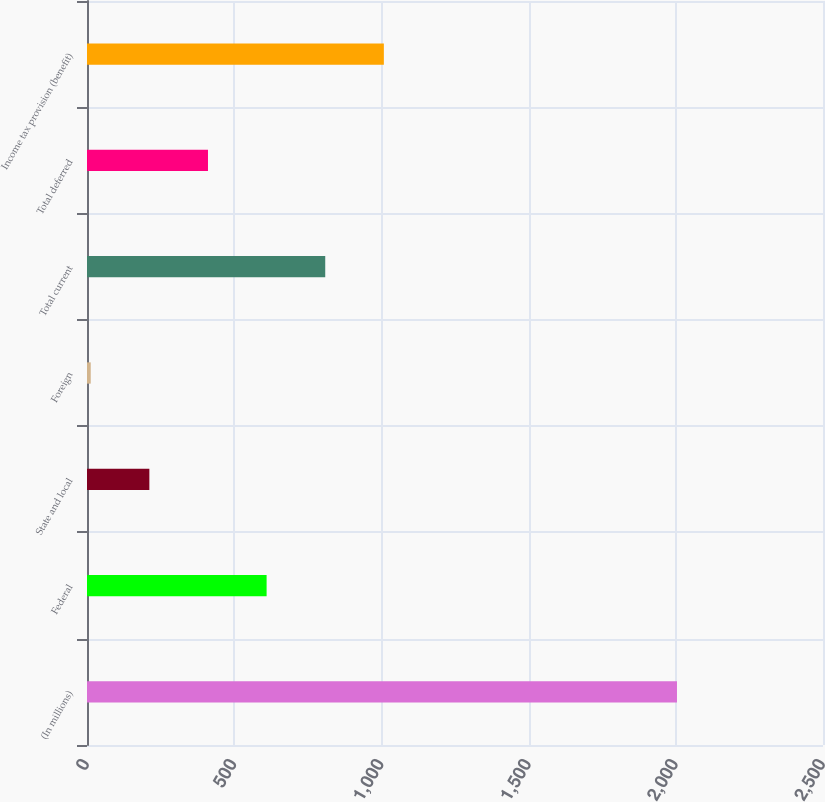Convert chart to OTSL. <chart><loc_0><loc_0><loc_500><loc_500><bar_chart><fcel>(In millions)<fcel>Federal<fcel>State and local<fcel>Foreign<fcel>Total current<fcel>Total deferred<fcel>Income tax provision (benefit)<nl><fcel>2004<fcel>610.09<fcel>211.83<fcel>12.7<fcel>809.22<fcel>410.96<fcel>1008.35<nl></chart> 